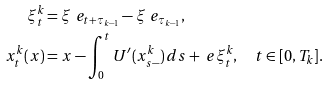Convert formula to latex. <formula><loc_0><loc_0><loc_500><loc_500>\xi ^ { k } _ { t } & = \xi ^ { \ } e _ { t + \tau _ { k - 1 } } - \xi ^ { \ } e _ { \tau _ { k - 1 } } , \\ x ^ { k } _ { t } ( x ) & = x - \int _ { 0 } ^ { t } U ^ { \prime } ( x ^ { k } _ { s - } ) \, d s + \ e \xi ^ { k } _ { t } , \quad t \in [ 0 , T _ { k } ] .</formula> 